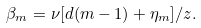<formula> <loc_0><loc_0><loc_500><loc_500>\beta _ { m } = \nu [ d ( m - 1 ) + \eta _ { m } ] / z .</formula> 